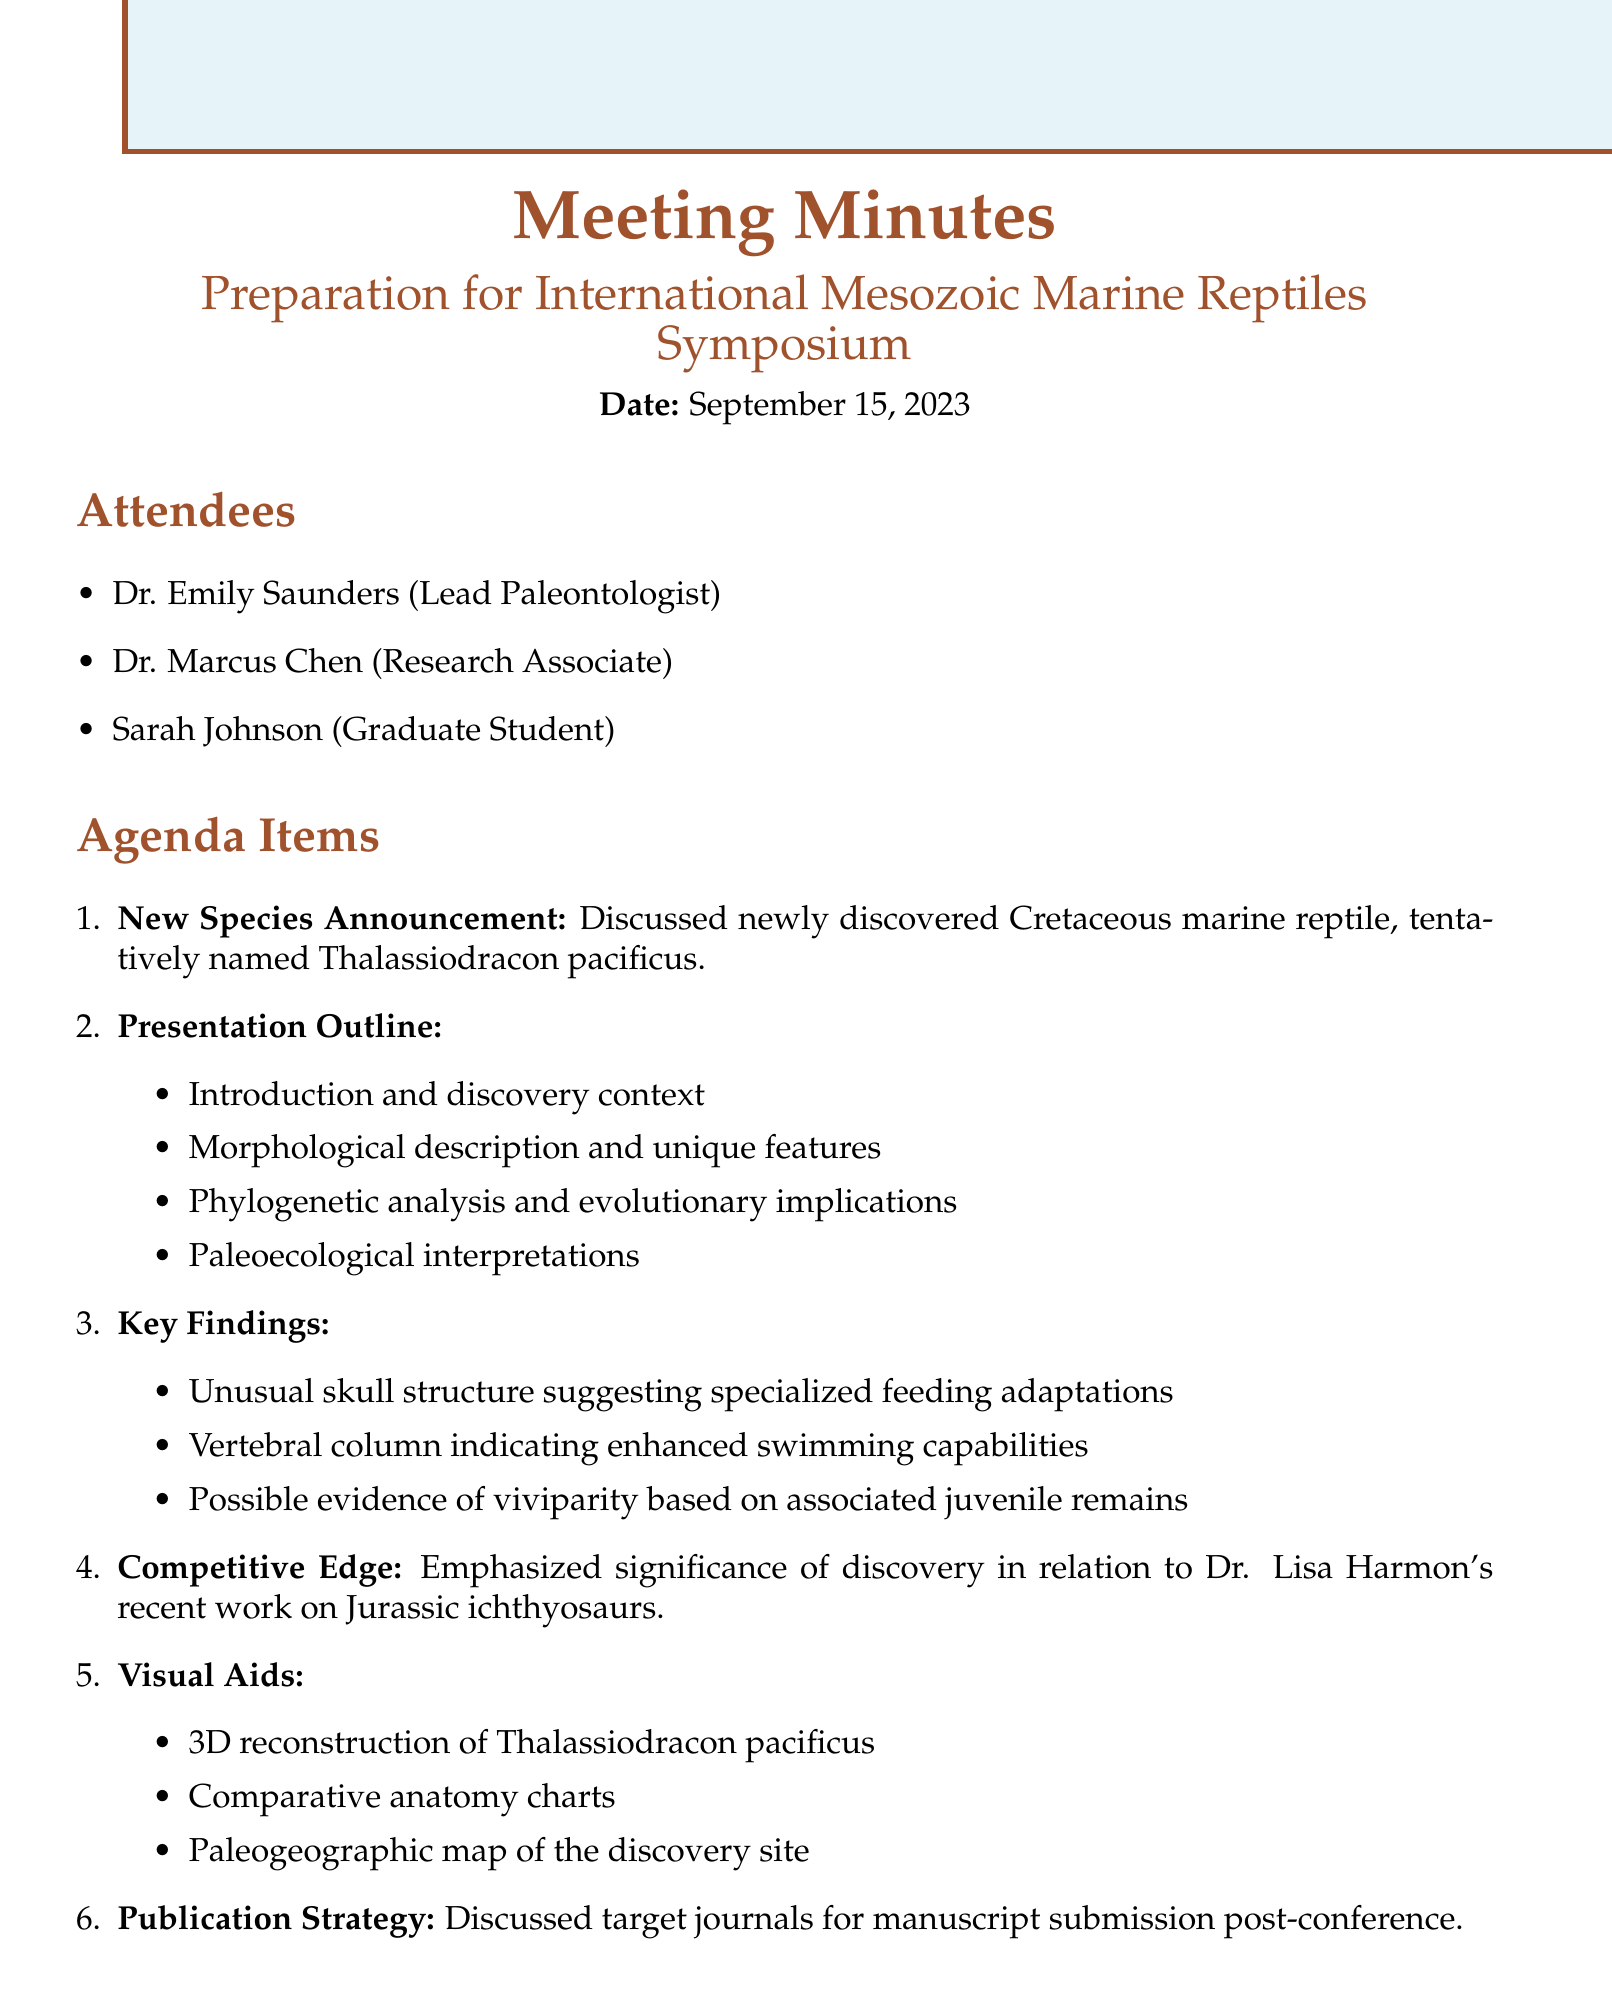What is the title of the meeting? The title is mentioned in the document as "Preparation for International Mesozoic Marine Reptiles Symposium."
Answer: Preparation for International Mesozoic Marine Reptiles Symposium Who is the lead paleontologist? The document lists Dr. Emily Saunders as the lead paleontologist.
Answer: Dr. Emily Saunders What is the tentative name of the newly discovered marine reptile? The newly discovered species is tentatively named Thalassiodracon pacificus.
Answer: Thalassiodracon pacificus How many agenda items were discussed? There are six agenda items outlined in the meeting minutes.
Answer: Six What specific feature indicates enhanced swimming capabilities? The document mentions the vertebral column as indicating enhanced swimming capabilities.
Answer: Vertebral column Which action item is assigned to Dr. Chen? Dr. Chen is responsible for finalizing the phylogenetic analysis according to the action items listed.
Answer: Finalize phylogenetic analysis What is the date of the next meeting? The document states the next meeting is scheduled for September 22, 2023.
Answer: September 22, 2023 What type of visual aids will be used in the presentation? The visual aids include a 3D reconstruction, comparative anatomy charts, and a paleogeographic map.
Answer: 3D reconstruction, comparative anatomy charts, paleogeographic map In relation to whom is the significance of the discovery emphasized? The significance of the discovery is emphasized in relation to Dr. Lisa Harmon's recent work.
Answer: Dr. Lisa Harmon 